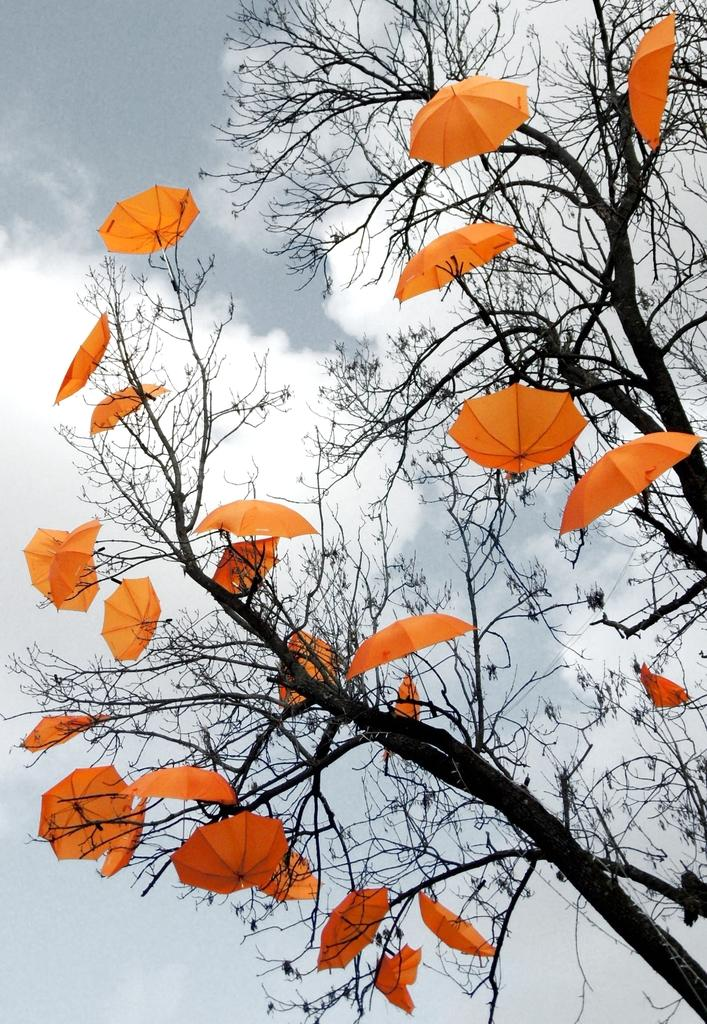What type of objects are attached to the trees in the image? There are umbrellas attached to the trees in the image. What can be seen in the background of the image? The sky is visible behind the trees in the image. What type of vegetable is being compared to the trees in the image? There is no vegetable being compared to the trees in the image. How does the image depict the act of rolling? The image does not depict any rolling motion or activity. 